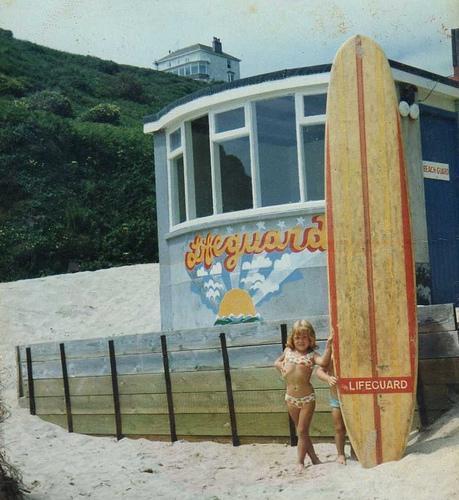How many people are in the photo?
Give a very brief answer. 2. 